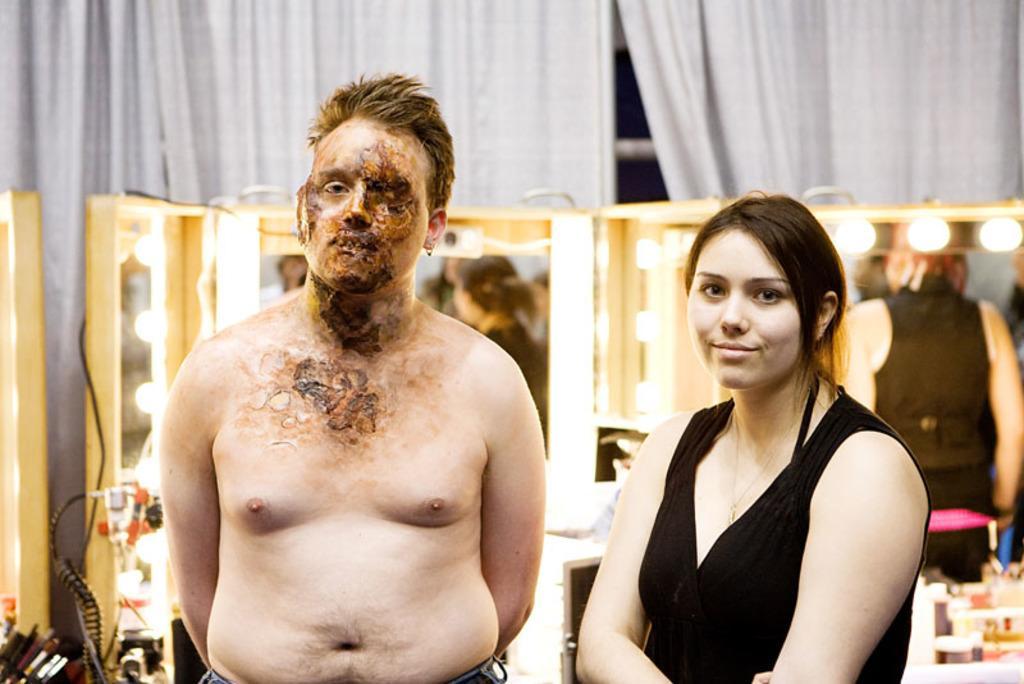Can you describe this image briefly? In this image we can see a man and a woman wearing black dress are standing. The background of the image is slightly blurred, where we can see the mirrors and see objects kept here, also we can see the curtains here. 